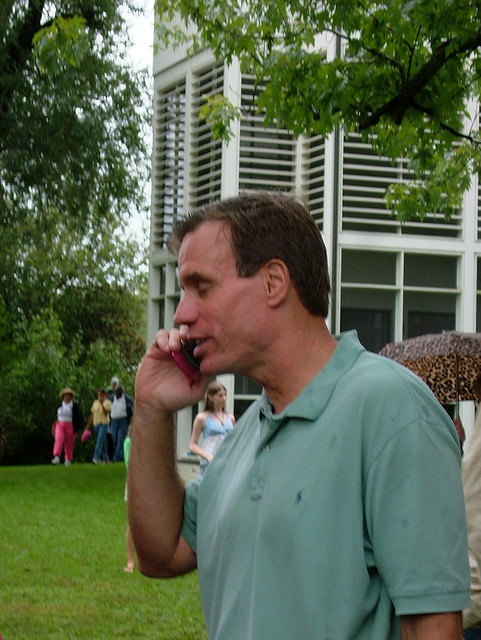Describe the objects in this image and their specific colors. I can see people in black, teal, and brown tones, umbrella in black, gray, and maroon tones, people in black, gray, and darkgray tones, people in black, maroon, and gray tones, and people in black, tan, darkblue, and olive tones in this image. 